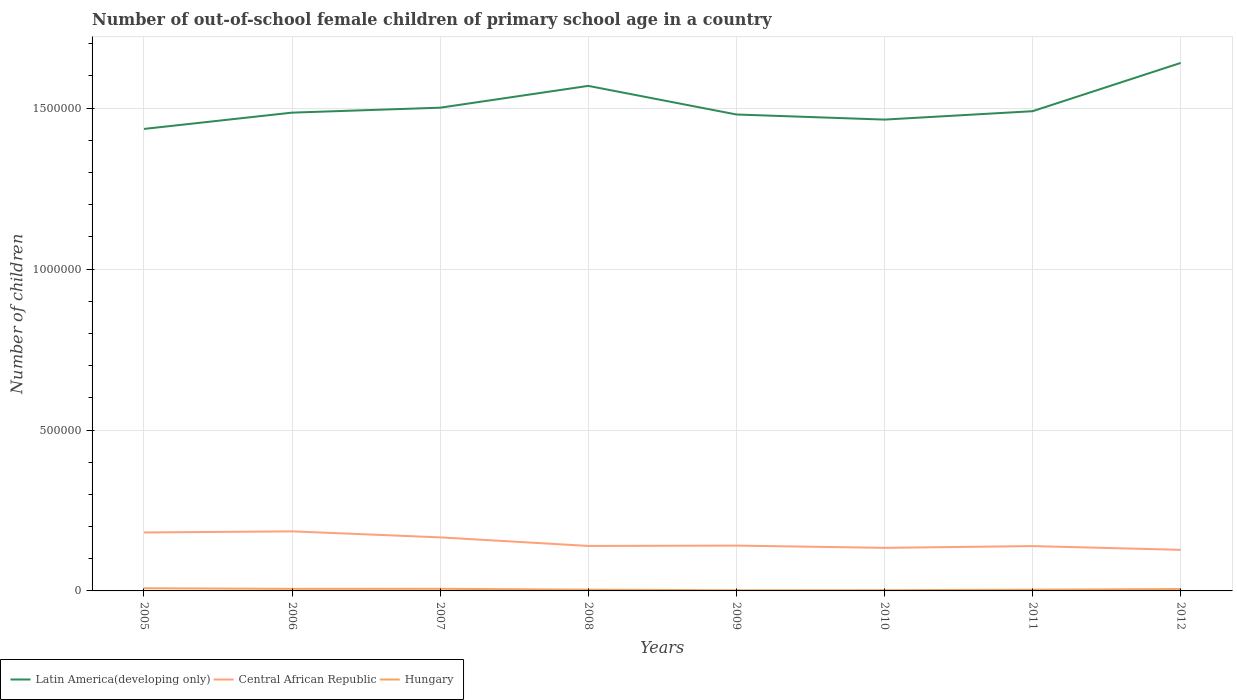How many different coloured lines are there?
Ensure brevity in your answer.  3. Does the line corresponding to Hungary intersect with the line corresponding to Central African Republic?
Your answer should be compact. No. Across all years, what is the maximum number of out-of-school female children in Central African Republic?
Offer a terse response. 1.28e+05. In which year was the number of out-of-school female children in Hungary maximum?
Offer a terse response. 2009. What is the total number of out-of-school female children in Hungary in the graph?
Give a very brief answer. 1621. What is the difference between the highest and the second highest number of out-of-school female children in Central African Republic?
Offer a terse response. 5.74e+04. How many years are there in the graph?
Offer a very short reply. 8. What is the difference between two consecutive major ticks on the Y-axis?
Provide a succinct answer. 5.00e+05. Are the values on the major ticks of Y-axis written in scientific E-notation?
Your answer should be compact. No. Does the graph contain any zero values?
Offer a very short reply. No. Does the graph contain grids?
Make the answer very short. Yes. How are the legend labels stacked?
Provide a succinct answer. Horizontal. What is the title of the graph?
Give a very brief answer. Number of out-of-school female children of primary school age in a country. Does "Serbia" appear as one of the legend labels in the graph?
Offer a very short reply. No. What is the label or title of the Y-axis?
Your response must be concise. Number of children. What is the Number of children in Latin America(developing only) in 2005?
Provide a short and direct response. 1.44e+06. What is the Number of children in Central African Republic in 2005?
Provide a short and direct response. 1.82e+05. What is the Number of children of Hungary in 2005?
Give a very brief answer. 8210. What is the Number of children of Latin America(developing only) in 2006?
Keep it short and to the point. 1.49e+06. What is the Number of children in Central African Republic in 2006?
Offer a terse response. 1.85e+05. What is the Number of children in Hungary in 2006?
Ensure brevity in your answer.  6465. What is the Number of children of Latin America(developing only) in 2007?
Offer a terse response. 1.50e+06. What is the Number of children in Central African Republic in 2007?
Give a very brief answer. 1.66e+05. What is the Number of children in Hungary in 2007?
Keep it short and to the point. 6589. What is the Number of children in Latin America(developing only) in 2008?
Give a very brief answer. 1.57e+06. What is the Number of children of Central African Republic in 2008?
Make the answer very short. 1.40e+05. What is the Number of children in Hungary in 2008?
Your response must be concise. 3879. What is the Number of children in Latin America(developing only) in 2009?
Your answer should be very brief. 1.48e+06. What is the Number of children of Central African Republic in 2009?
Ensure brevity in your answer.  1.41e+05. What is the Number of children in Hungary in 2009?
Your answer should be compact. 2098. What is the Number of children of Latin America(developing only) in 2010?
Offer a terse response. 1.46e+06. What is the Number of children of Central African Republic in 2010?
Your answer should be compact. 1.34e+05. What is the Number of children in Hungary in 2010?
Ensure brevity in your answer.  2276. What is the Number of children of Latin America(developing only) in 2011?
Ensure brevity in your answer.  1.49e+06. What is the Number of children of Central African Republic in 2011?
Your answer should be very brief. 1.39e+05. What is the Number of children in Hungary in 2011?
Your response must be concise. 3832. What is the Number of children of Latin America(developing only) in 2012?
Your response must be concise. 1.64e+06. What is the Number of children of Central African Republic in 2012?
Your response must be concise. 1.28e+05. What is the Number of children of Hungary in 2012?
Your response must be concise. 5886. Across all years, what is the maximum Number of children of Latin America(developing only)?
Offer a very short reply. 1.64e+06. Across all years, what is the maximum Number of children of Central African Republic?
Offer a very short reply. 1.85e+05. Across all years, what is the maximum Number of children of Hungary?
Keep it short and to the point. 8210. Across all years, what is the minimum Number of children of Latin America(developing only)?
Provide a succinct answer. 1.44e+06. Across all years, what is the minimum Number of children in Central African Republic?
Your answer should be very brief. 1.28e+05. Across all years, what is the minimum Number of children in Hungary?
Offer a terse response. 2098. What is the total Number of children of Latin America(developing only) in the graph?
Make the answer very short. 1.21e+07. What is the total Number of children of Central African Republic in the graph?
Your answer should be very brief. 1.21e+06. What is the total Number of children of Hungary in the graph?
Your answer should be very brief. 3.92e+04. What is the difference between the Number of children of Latin America(developing only) in 2005 and that in 2006?
Your response must be concise. -5.06e+04. What is the difference between the Number of children in Central African Republic in 2005 and that in 2006?
Make the answer very short. -3494. What is the difference between the Number of children of Hungary in 2005 and that in 2006?
Give a very brief answer. 1745. What is the difference between the Number of children in Latin America(developing only) in 2005 and that in 2007?
Ensure brevity in your answer.  -6.60e+04. What is the difference between the Number of children of Central African Republic in 2005 and that in 2007?
Keep it short and to the point. 1.52e+04. What is the difference between the Number of children in Hungary in 2005 and that in 2007?
Ensure brevity in your answer.  1621. What is the difference between the Number of children of Latin America(developing only) in 2005 and that in 2008?
Offer a terse response. -1.34e+05. What is the difference between the Number of children of Central African Republic in 2005 and that in 2008?
Ensure brevity in your answer.  4.18e+04. What is the difference between the Number of children in Hungary in 2005 and that in 2008?
Offer a terse response. 4331. What is the difference between the Number of children in Latin America(developing only) in 2005 and that in 2009?
Provide a short and direct response. -4.49e+04. What is the difference between the Number of children of Central African Republic in 2005 and that in 2009?
Provide a short and direct response. 4.08e+04. What is the difference between the Number of children in Hungary in 2005 and that in 2009?
Offer a very short reply. 6112. What is the difference between the Number of children in Latin America(developing only) in 2005 and that in 2010?
Your answer should be very brief. -2.90e+04. What is the difference between the Number of children of Central African Republic in 2005 and that in 2010?
Your answer should be very brief. 4.77e+04. What is the difference between the Number of children of Hungary in 2005 and that in 2010?
Make the answer very short. 5934. What is the difference between the Number of children of Latin America(developing only) in 2005 and that in 2011?
Provide a short and direct response. -5.51e+04. What is the difference between the Number of children of Central African Republic in 2005 and that in 2011?
Offer a very short reply. 4.23e+04. What is the difference between the Number of children of Hungary in 2005 and that in 2011?
Keep it short and to the point. 4378. What is the difference between the Number of children of Latin America(developing only) in 2005 and that in 2012?
Your response must be concise. -2.05e+05. What is the difference between the Number of children of Central African Republic in 2005 and that in 2012?
Provide a short and direct response. 5.39e+04. What is the difference between the Number of children in Hungary in 2005 and that in 2012?
Your answer should be compact. 2324. What is the difference between the Number of children in Latin America(developing only) in 2006 and that in 2007?
Make the answer very short. -1.53e+04. What is the difference between the Number of children of Central African Republic in 2006 and that in 2007?
Provide a succinct answer. 1.87e+04. What is the difference between the Number of children of Hungary in 2006 and that in 2007?
Your response must be concise. -124. What is the difference between the Number of children of Latin America(developing only) in 2006 and that in 2008?
Your response must be concise. -8.31e+04. What is the difference between the Number of children in Central African Republic in 2006 and that in 2008?
Your answer should be very brief. 4.53e+04. What is the difference between the Number of children of Hungary in 2006 and that in 2008?
Keep it short and to the point. 2586. What is the difference between the Number of children of Latin America(developing only) in 2006 and that in 2009?
Provide a succinct answer. 5729. What is the difference between the Number of children in Central African Republic in 2006 and that in 2009?
Your answer should be compact. 4.43e+04. What is the difference between the Number of children of Hungary in 2006 and that in 2009?
Provide a short and direct response. 4367. What is the difference between the Number of children of Latin America(developing only) in 2006 and that in 2010?
Keep it short and to the point. 2.16e+04. What is the difference between the Number of children in Central African Republic in 2006 and that in 2010?
Provide a succinct answer. 5.12e+04. What is the difference between the Number of children in Hungary in 2006 and that in 2010?
Give a very brief answer. 4189. What is the difference between the Number of children in Latin America(developing only) in 2006 and that in 2011?
Make the answer very short. -4454. What is the difference between the Number of children of Central African Republic in 2006 and that in 2011?
Offer a terse response. 4.58e+04. What is the difference between the Number of children in Hungary in 2006 and that in 2011?
Offer a terse response. 2633. What is the difference between the Number of children in Latin America(developing only) in 2006 and that in 2012?
Your answer should be compact. -1.54e+05. What is the difference between the Number of children of Central African Republic in 2006 and that in 2012?
Provide a short and direct response. 5.74e+04. What is the difference between the Number of children of Hungary in 2006 and that in 2012?
Provide a succinct answer. 579. What is the difference between the Number of children of Latin America(developing only) in 2007 and that in 2008?
Provide a succinct answer. -6.78e+04. What is the difference between the Number of children of Central African Republic in 2007 and that in 2008?
Ensure brevity in your answer.  2.66e+04. What is the difference between the Number of children in Hungary in 2007 and that in 2008?
Make the answer very short. 2710. What is the difference between the Number of children in Latin America(developing only) in 2007 and that in 2009?
Make the answer very short. 2.11e+04. What is the difference between the Number of children in Central African Republic in 2007 and that in 2009?
Provide a succinct answer. 2.56e+04. What is the difference between the Number of children in Hungary in 2007 and that in 2009?
Make the answer very short. 4491. What is the difference between the Number of children of Latin America(developing only) in 2007 and that in 2010?
Your answer should be compact. 3.70e+04. What is the difference between the Number of children of Central African Republic in 2007 and that in 2010?
Your response must be concise. 3.25e+04. What is the difference between the Number of children of Hungary in 2007 and that in 2010?
Your answer should be compact. 4313. What is the difference between the Number of children in Latin America(developing only) in 2007 and that in 2011?
Your answer should be very brief. 1.09e+04. What is the difference between the Number of children of Central African Republic in 2007 and that in 2011?
Provide a short and direct response. 2.71e+04. What is the difference between the Number of children in Hungary in 2007 and that in 2011?
Offer a terse response. 2757. What is the difference between the Number of children in Latin America(developing only) in 2007 and that in 2012?
Ensure brevity in your answer.  -1.39e+05. What is the difference between the Number of children of Central African Republic in 2007 and that in 2012?
Offer a terse response. 3.87e+04. What is the difference between the Number of children in Hungary in 2007 and that in 2012?
Give a very brief answer. 703. What is the difference between the Number of children in Latin America(developing only) in 2008 and that in 2009?
Offer a very short reply. 8.88e+04. What is the difference between the Number of children in Central African Republic in 2008 and that in 2009?
Your answer should be compact. -1034. What is the difference between the Number of children of Hungary in 2008 and that in 2009?
Ensure brevity in your answer.  1781. What is the difference between the Number of children in Latin America(developing only) in 2008 and that in 2010?
Your answer should be very brief. 1.05e+05. What is the difference between the Number of children in Central African Republic in 2008 and that in 2010?
Ensure brevity in your answer.  5907. What is the difference between the Number of children of Hungary in 2008 and that in 2010?
Ensure brevity in your answer.  1603. What is the difference between the Number of children in Latin America(developing only) in 2008 and that in 2011?
Offer a very short reply. 7.87e+04. What is the difference between the Number of children of Central African Republic in 2008 and that in 2011?
Make the answer very short. 487. What is the difference between the Number of children in Latin America(developing only) in 2008 and that in 2012?
Make the answer very short. -7.13e+04. What is the difference between the Number of children in Central African Republic in 2008 and that in 2012?
Offer a very short reply. 1.21e+04. What is the difference between the Number of children of Hungary in 2008 and that in 2012?
Provide a succinct answer. -2007. What is the difference between the Number of children in Latin America(developing only) in 2009 and that in 2010?
Ensure brevity in your answer.  1.59e+04. What is the difference between the Number of children of Central African Republic in 2009 and that in 2010?
Ensure brevity in your answer.  6941. What is the difference between the Number of children of Hungary in 2009 and that in 2010?
Your answer should be compact. -178. What is the difference between the Number of children in Latin America(developing only) in 2009 and that in 2011?
Offer a very short reply. -1.02e+04. What is the difference between the Number of children in Central African Republic in 2009 and that in 2011?
Offer a terse response. 1521. What is the difference between the Number of children in Hungary in 2009 and that in 2011?
Make the answer very short. -1734. What is the difference between the Number of children in Latin America(developing only) in 2009 and that in 2012?
Offer a terse response. -1.60e+05. What is the difference between the Number of children in Central African Republic in 2009 and that in 2012?
Offer a terse response. 1.31e+04. What is the difference between the Number of children in Hungary in 2009 and that in 2012?
Your answer should be compact. -3788. What is the difference between the Number of children of Latin America(developing only) in 2010 and that in 2011?
Provide a short and direct response. -2.61e+04. What is the difference between the Number of children in Central African Republic in 2010 and that in 2011?
Offer a terse response. -5420. What is the difference between the Number of children of Hungary in 2010 and that in 2011?
Give a very brief answer. -1556. What is the difference between the Number of children in Latin America(developing only) in 2010 and that in 2012?
Give a very brief answer. -1.76e+05. What is the difference between the Number of children of Central African Republic in 2010 and that in 2012?
Give a very brief answer. 6178. What is the difference between the Number of children in Hungary in 2010 and that in 2012?
Keep it short and to the point. -3610. What is the difference between the Number of children in Latin America(developing only) in 2011 and that in 2012?
Give a very brief answer. -1.50e+05. What is the difference between the Number of children of Central African Republic in 2011 and that in 2012?
Provide a succinct answer. 1.16e+04. What is the difference between the Number of children in Hungary in 2011 and that in 2012?
Ensure brevity in your answer.  -2054. What is the difference between the Number of children in Latin America(developing only) in 2005 and the Number of children in Central African Republic in 2006?
Provide a succinct answer. 1.25e+06. What is the difference between the Number of children in Latin America(developing only) in 2005 and the Number of children in Hungary in 2006?
Provide a succinct answer. 1.43e+06. What is the difference between the Number of children in Central African Republic in 2005 and the Number of children in Hungary in 2006?
Keep it short and to the point. 1.75e+05. What is the difference between the Number of children in Latin America(developing only) in 2005 and the Number of children in Central African Republic in 2007?
Ensure brevity in your answer.  1.27e+06. What is the difference between the Number of children of Latin America(developing only) in 2005 and the Number of children of Hungary in 2007?
Keep it short and to the point. 1.43e+06. What is the difference between the Number of children in Central African Republic in 2005 and the Number of children in Hungary in 2007?
Provide a short and direct response. 1.75e+05. What is the difference between the Number of children of Latin America(developing only) in 2005 and the Number of children of Central African Republic in 2008?
Offer a terse response. 1.30e+06. What is the difference between the Number of children of Latin America(developing only) in 2005 and the Number of children of Hungary in 2008?
Your answer should be very brief. 1.43e+06. What is the difference between the Number of children in Central African Republic in 2005 and the Number of children in Hungary in 2008?
Keep it short and to the point. 1.78e+05. What is the difference between the Number of children in Latin America(developing only) in 2005 and the Number of children in Central African Republic in 2009?
Offer a very short reply. 1.29e+06. What is the difference between the Number of children of Latin America(developing only) in 2005 and the Number of children of Hungary in 2009?
Offer a very short reply. 1.43e+06. What is the difference between the Number of children of Central African Republic in 2005 and the Number of children of Hungary in 2009?
Keep it short and to the point. 1.80e+05. What is the difference between the Number of children in Latin America(developing only) in 2005 and the Number of children in Central African Republic in 2010?
Keep it short and to the point. 1.30e+06. What is the difference between the Number of children of Latin America(developing only) in 2005 and the Number of children of Hungary in 2010?
Make the answer very short. 1.43e+06. What is the difference between the Number of children in Central African Republic in 2005 and the Number of children in Hungary in 2010?
Provide a short and direct response. 1.79e+05. What is the difference between the Number of children of Latin America(developing only) in 2005 and the Number of children of Central African Republic in 2011?
Ensure brevity in your answer.  1.30e+06. What is the difference between the Number of children of Latin America(developing only) in 2005 and the Number of children of Hungary in 2011?
Your answer should be very brief. 1.43e+06. What is the difference between the Number of children in Central African Republic in 2005 and the Number of children in Hungary in 2011?
Keep it short and to the point. 1.78e+05. What is the difference between the Number of children in Latin America(developing only) in 2005 and the Number of children in Central African Republic in 2012?
Your answer should be very brief. 1.31e+06. What is the difference between the Number of children of Latin America(developing only) in 2005 and the Number of children of Hungary in 2012?
Keep it short and to the point. 1.43e+06. What is the difference between the Number of children in Central African Republic in 2005 and the Number of children in Hungary in 2012?
Offer a terse response. 1.76e+05. What is the difference between the Number of children in Latin America(developing only) in 2006 and the Number of children in Central African Republic in 2007?
Offer a terse response. 1.32e+06. What is the difference between the Number of children in Latin America(developing only) in 2006 and the Number of children in Hungary in 2007?
Your answer should be very brief. 1.48e+06. What is the difference between the Number of children in Central African Republic in 2006 and the Number of children in Hungary in 2007?
Your answer should be compact. 1.79e+05. What is the difference between the Number of children in Latin America(developing only) in 2006 and the Number of children in Central African Republic in 2008?
Make the answer very short. 1.35e+06. What is the difference between the Number of children of Latin America(developing only) in 2006 and the Number of children of Hungary in 2008?
Your response must be concise. 1.48e+06. What is the difference between the Number of children of Central African Republic in 2006 and the Number of children of Hungary in 2008?
Your response must be concise. 1.81e+05. What is the difference between the Number of children in Latin America(developing only) in 2006 and the Number of children in Central African Republic in 2009?
Provide a short and direct response. 1.35e+06. What is the difference between the Number of children of Latin America(developing only) in 2006 and the Number of children of Hungary in 2009?
Your response must be concise. 1.48e+06. What is the difference between the Number of children in Central African Republic in 2006 and the Number of children in Hungary in 2009?
Ensure brevity in your answer.  1.83e+05. What is the difference between the Number of children of Latin America(developing only) in 2006 and the Number of children of Central African Republic in 2010?
Your answer should be very brief. 1.35e+06. What is the difference between the Number of children in Latin America(developing only) in 2006 and the Number of children in Hungary in 2010?
Offer a very short reply. 1.48e+06. What is the difference between the Number of children of Central African Republic in 2006 and the Number of children of Hungary in 2010?
Keep it short and to the point. 1.83e+05. What is the difference between the Number of children in Latin America(developing only) in 2006 and the Number of children in Central African Republic in 2011?
Ensure brevity in your answer.  1.35e+06. What is the difference between the Number of children of Latin America(developing only) in 2006 and the Number of children of Hungary in 2011?
Offer a terse response. 1.48e+06. What is the difference between the Number of children in Central African Republic in 2006 and the Number of children in Hungary in 2011?
Offer a terse response. 1.81e+05. What is the difference between the Number of children of Latin America(developing only) in 2006 and the Number of children of Central African Republic in 2012?
Provide a short and direct response. 1.36e+06. What is the difference between the Number of children in Latin America(developing only) in 2006 and the Number of children in Hungary in 2012?
Provide a short and direct response. 1.48e+06. What is the difference between the Number of children of Central African Republic in 2006 and the Number of children of Hungary in 2012?
Make the answer very short. 1.79e+05. What is the difference between the Number of children of Latin America(developing only) in 2007 and the Number of children of Central African Republic in 2008?
Provide a short and direct response. 1.36e+06. What is the difference between the Number of children of Latin America(developing only) in 2007 and the Number of children of Hungary in 2008?
Your answer should be compact. 1.50e+06. What is the difference between the Number of children of Central African Republic in 2007 and the Number of children of Hungary in 2008?
Your answer should be compact. 1.63e+05. What is the difference between the Number of children in Latin America(developing only) in 2007 and the Number of children in Central African Republic in 2009?
Offer a very short reply. 1.36e+06. What is the difference between the Number of children in Latin America(developing only) in 2007 and the Number of children in Hungary in 2009?
Keep it short and to the point. 1.50e+06. What is the difference between the Number of children in Central African Republic in 2007 and the Number of children in Hungary in 2009?
Your response must be concise. 1.64e+05. What is the difference between the Number of children of Latin America(developing only) in 2007 and the Number of children of Central African Republic in 2010?
Provide a short and direct response. 1.37e+06. What is the difference between the Number of children of Latin America(developing only) in 2007 and the Number of children of Hungary in 2010?
Provide a short and direct response. 1.50e+06. What is the difference between the Number of children of Central African Republic in 2007 and the Number of children of Hungary in 2010?
Provide a short and direct response. 1.64e+05. What is the difference between the Number of children in Latin America(developing only) in 2007 and the Number of children in Central African Republic in 2011?
Offer a terse response. 1.36e+06. What is the difference between the Number of children of Latin America(developing only) in 2007 and the Number of children of Hungary in 2011?
Ensure brevity in your answer.  1.50e+06. What is the difference between the Number of children in Central African Republic in 2007 and the Number of children in Hungary in 2011?
Your answer should be compact. 1.63e+05. What is the difference between the Number of children in Latin America(developing only) in 2007 and the Number of children in Central African Republic in 2012?
Give a very brief answer. 1.37e+06. What is the difference between the Number of children in Latin America(developing only) in 2007 and the Number of children in Hungary in 2012?
Your response must be concise. 1.50e+06. What is the difference between the Number of children of Central African Republic in 2007 and the Number of children of Hungary in 2012?
Your response must be concise. 1.61e+05. What is the difference between the Number of children in Latin America(developing only) in 2008 and the Number of children in Central African Republic in 2009?
Your answer should be very brief. 1.43e+06. What is the difference between the Number of children in Latin America(developing only) in 2008 and the Number of children in Hungary in 2009?
Offer a very short reply. 1.57e+06. What is the difference between the Number of children of Central African Republic in 2008 and the Number of children of Hungary in 2009?
Offer a very short reply. 1.38e+05. What is the difference between the Number of children in Latin America(developing only) in 2008 and the Number of children in Central African Republic in 2010?
Keep it short and to the point. 1.44e+06. What is the difference between the Number of children in Latin America(developing only) in 2008 and the Number of children in Hungary in 2010?
Provide a succinct answer. 1.57e+06. What is the difference between the Number of children in Central African Republic in 2008 and the Number of children in Hungary in 2010?
Make the answer very short. 1.37e+05. What is the difference between the Number of children in Latin America(developing only) in 2008 and the Number of children in Central African Republic in 2011?
Your response must be concise. 1.43e+06. What is the difference between the Number of children in Latin America(developing only) in 2008 and the Number of children in Hungary in 2011?
Offer a very short reply. 1.57e+06. What is the difference between the Number of children of Central African Republic in 2008 and the Number of children of Hungary in 2011?
Ensure brevity in your answer.  1.36e+05. What is the difference between the Number of children of Latin America(developing only) in 2008 and the Number of children of Central African Republic in 2012?
Make the answer very short. 1.44e+06. What is the difference between the Number of children in Latin America(developing only) in 2008 and the Number of children in Hungary in 2012?
Ensure brevity in your answer.  1.56e+06. What is the difference between the Number of children of Central African Republic in 2008 and the Number of children of Hungary in 2012?
Provide a short and direct response. 1.34e+05. What is the difference between the Number of children of Latin America(developing only) in 2009 and the Number of children of Central African Republic in 2010?
Your answer should be compact. 1.35e+06. What is the difference between the Number of children in Latin America(developing only) in 2009 and the Number of children in Hungary in 2010?
Your answer should be very brief. 1.48e+06. What is the difference between the Number of children of Central African Republic in 2009 and the Number of children of Hungary in 2010?
Offer a very short reply. 1.39e+05. What is the difference between the Number of children in Latin America(developing only) in 2009 and the Number of children in Central African Republic in 2011?
Your answer should be very brief. 1.34e+06. What is the difference between the Number of children of Latin America(developing only) in 2009 and the Number of children of Hungary in 2011?
Make the answer very short. 1.48e+06. What is the difference between the Number of children of Central African Republic in 2009 and the Number of children of Hungary in 2011?
Your response must be concise. 1.37e+05. What is the difference between the Number of children in Latin America(developing only) in 2009 and the Number of children in Central African Republic in 2012?
Offer a very short reply. 1.35e+06. What is the difference between the Number of children in Latin America(developing only) in 2009 and the Number of children in Hungary in 2012?
Give a very brief answer. 1.47e+06. What is the difference between the Number of children in Central African Republic in 2009 and the Number of children in Hungary in 2012?
Keep it short and to the point. 1.35e+05. What is the difference between the Number of children of Latin America(developing only) in 2010 and the Number of children of Central African Republic in 2011?
Make the answer very short. 1.33e+06. What is the difference between the Number of children of Latin America(developing only) in 2010 and the Number of children of Hungary in 2011?
Ensure brevity in your answer.  1.46e+06. What is the difference between the Number of children of Central African Republic in 2010 and the Number of children of Hungary in 2011?
Your answer should be compact. 1.30e+05. What is the difference between the Number of children in Latin America(developing only) in 2010 and the Number of children in Central African Republic in 2012?
Offer a terse response. 1.34e+06. What is the difference between the Number of children in Latin America(developing only) in 2010 and the Number of children in Hungary in 2012?
Offer a very short reply. 1.46e+06. What is the difference between the Number of children of Central African Republic in 2010 and the Number of children of Hungary in 2012?
Make the answer very short. 1.28e+05. What is the difference between the Number of children in Latin America(developing only) in 2011 and the Number of children in Central African Republic in 2012?
Provide a short and direct response. 1.36e+06. What is the difference between the Number of children of Latin America(developing only) in 2011 and the Number of children of Hungary in 2012?
Your response must be concise. 1.48e+06. What is the difference between the Number of children of Central African Republic in 2011 and the Number of children of Hungary in 2012?
Your response must be concise. 1.33e+05. What is the average Number of children of Latin America(developing only) per year?
Your answer should be very brief. 1.51e+06. What is the average Number of children of Central African Republic per year?
Make the answer very short. 1.52e+05. What is the average Number of children of Hungary per year?
Give a very brief answer. 4904.38. In the year 2005, what is the difference between the Number of children in Latin America(developing only) and Number of children in Central African Republic?
Your response must be concise. 1.25e+06. In the year 2005, what is the difference between the Number of children of Latin America(developing only) and Number of children of Hungary?
Offer a terse response. 1.43e+06. In the year 2005, what is the difference between the Number of children of Central African Republic and Number of children of Hungary?
Your answer should be compact. 1.73e+05. In the year 2006, what is the difference between the Number of children of Latin America(developing only) and Number of children of Central African Republic?
Give a very brief answer. 1.30e+06. In the year 2006, what is the difference between the Number of children of Latin America(developing only) and Number of children of Hungary?
Your response must be concise. 1.48e+06. In the year 2006, what is the difference between the Number of children in Central African Republic and Number of children in Hungary?
Provide a short and direct response. 1.79e+05. In the year 2007, what is the difference between the Number of children in Latin America(developing only) and Number of children in Central African Republic?
Make the answer very short. 1.34e+06. In the year 2007, what is the difference between the Number of children in Latin America(developing only) and Number of children in Hungary?
Provide a succinct answer. 1.49e+06. In the year 2007, what is the difference between the Number of children of Central African Republic and Number of children of Hungary?
Your response must be concise. 1.60e+05. In the year 2008, what is the difference between the Number of children in Latin America(developing only) and Number of children in Central African Republic?
Make the answer very short. 1.43e+06. In the year 2008, what is the difference between the Number of children in Latin America(developing only) and Number of children in Hungary?
Provide a short and direct response. 1.57e+06. In the year 2008, what is the difference between the Number of children of Central African Republic and Number of children of Hungary?
Provide a short and direct response. 1.36e+05. In the year 2009, what is the difference between the Number of children of Latin America(developing only) and Number of children of Central African Republic?
Your answer should be very brief. 1.34e+06. In the year 2009, what is the difference between the Number of children in Latin America(developing only) and Number of children in Hungary?
Offer a very short reply. 1.48e+06. In the year 2009, what is the difference between the Number of children of Central African Republic and Number of children of Hungary?
Offer a terse response. 1.39e+05. In the year 2010, what is the difference between the Number of children of Latin America(developing only) and Number of children of Central African Republic?
Provide a short and direct response. 1.33e+06. In the year 2010, what is the difference between the Number of children in Latin America(developing only) and Number of children in Hungary?
Your answer should be compact. 1.46e+06. In the year 2010, what is the difference between the Number of children of Central African Republic and Number of children of Hungary?
Offer a terse response. 1.32e+05. In the year 2011, what is the difference between the Number of children of Latin America(developing only) and Number of children of Central African Republic?
Ensure brevity in your answer.  1.35e+06. In the year 2011, what is the difference between the Number of children in Latin America(developing only) and Number of children in Hungary?
Your response must be concise. 1.49e+06. In the year 2011, what is the difference between the Number of children in Central African Republic and Number of children in Hungary?
Keep it short and to the point. 1.35e+05. In the year 2012, what is the difference between the Number of children of Latin America(developing only) and Number of children of Central African Republic?
Offer a terse response. 1.51e+06. In the year 2012, what is the difference between the Number of children in Latin America(developing only) and Number of children in Hungary?
Your response must be concise. 1.63e+06. In the year 2012, what is the difference between the Number of children of Central African Republic and Number of children of Hungary?
Make the answer very short. 1.22e+05. What is the ratio of the Number of children of Latin America(developing only) in 2005 to that in 2006?
Offer a very short reply. 0.97. What is the ratio of the Number of children of Central African Republic in 2005 to that in 2006?
Your answer should be very brief. 0.98. What is the ratio of the Number of children of Hungary in 2005 to that in 2006?
Your answer should be very brief. 1.27. What is the ratio of the Number of children of Latin America(developing only) in 2005 to that in 2007?
Offer a very short reply. 0.96. What is the ratio of the Number of children of Central African Republic in 2005 to that in 2007?
Your response must be concise. 1.09. What is the ratio of the Number of children in Hungary in 2005 to that in 2007?
Keep it short and to the point. 1.25. What is the ratio of the Number of children of Latin America(developing only) in 2005 to that in 2008?
Give a very brief answer. 0.91. What is the ratio of the Number of children in Central African Republic in 2005 to that in 2008?
Your answer should be very brief. 1.3. What is the ratio of the Number of children of Hungary in 2005 to that in 2008?
Give a very brief answer. 2.12. What is the ratio of the Number of children of Latin America(developing only) in 2005 to that in 2009?
Offer a very short reply. 0.97. What is the ratio of the Number of children in Central African Republic in 2005 to that in 2009?
Offer a very short reply. 1.29. What is the ratio of the Number of children in Hungary in 2005 to that in 2009?
Ensure brevity in your answer.  3.91. What is the ratio of the Number of children in Latin America(developing only) in 2005 to that in 2010?
Your answer should be compact. 0.98. What is the ratio of the Number of children in Central African Republic in 2005 to that in 2010?
Your answer should be compact. 1.36. What is the ratio of the Number of children in Hungary in 2005 to that in 2010?
Give a very brief answer. 3.61. What is the ratio of the Number of children in Latin America(developing only) in 2005 to that in 2011?
Make the answer very short. 0.96. What is the ratio of the Number of children in Central African Republic in 2005 to that in 2011?
Offer a very short reply. 1.3. What is the ratio of the Number of children of Hungary in 2005 to that in 2011?
Offer a terse response. 2.14. What is the ratio of the Number of children in Latin America(developing only) in 2005 to that in 2012?
Your answer should be compact. 0.88. What is the ratio of the Number of children of Central African Republic in 2005 to that in 2012?
Your answer should be very brief. 1.42. What is the ratio of the Number of children of Hungary in 2005 to that in 2012?
Make the answer very short. 1.39. What is the ratio of the Number of children in Latin America(developing only) in 2006 to that in 2007?
Provide a short and direct response. 0.99. What is the ratio of the Number of children in Central African Republic in 2006 to that in 2007?
Provide a succinct answer. 1.11. What is the ratio of the Number of children of Hungary in 2006 to that in 2007?
Provide a succinct answer. 0.98. What is the ratio of the Number of children of Latin America(developing only) in 2006 to that in 2008?
Give a very brief answer. 0.95. What is the ratio of the Number of children in Central African Republic in 2006 to that in 2008?
Offer a very short reply. 1.32. What is the ratio of the Number of children in Hungary in 2006 to that in 2008?
Your response must be concise. 1.67. What is the ratio of the Number of children in Central African Republic in 2006 to that in 2009?
Offer a very short reply. 1.31. What is the ratio of the Number of children in Hungary in 2006 to that in 2009?
Offer a very short reply. 3.08. What is the ratio of the Number of children in Latin America(developing only) in 2006 to that in 2010?
Offer a terse response. 1.01. What is the ratio of the Number of children of Central African Republic in 2006 to that in 2010?
Give a very brief answer. 1.38. What is the ratio of the Number of children of Hungary in 2006 to that in 2010?
Give a very brief answer. 2.84. What is the ratio of the Number of children in Central African Republic in 2006 to that in 2011?
Ensure brevity in your answer.  1.33. What is the ratio of the Number of children of Hungary in 2006 to that in 2011?
Your answer should be compact. 1.69. What is the ratio of the Number of children of Latin America(developing only) in 2006 to that in 2012?
Give a very brief answer. 0.91. What is the ratio of the Number of children of Central African Republic in 2006 to that in 2012?
Provide a succinct answer. 1.45. What is the ratio of the Number of children in Hungary in 2006 to that in 2012?
Offer a terse response. 1.1. What is the ratio of the Number of children in Latin America(developing only) in 2007 to that in 2008?
Make the answer very short. 0.96. What is the ratio of the Number of children in Central African Republic in 2007 to that in 2008?
Ensure brevity in your answer.  1.19. What is the ratio of the Number of children in Hungary in 2007 to that in 2008?
Your answer should be compact. 1.7. What is the ratio of the Number of children of Latin America(developing only) in 2007 to that in 2009?
Keep it short and to the point. 1.01. What is the ratio of the Number of children in Central African Republic in 2007 to that in 2009?
Offer a very short reply. 1.18. What is the ratio of the Number of children of Hungary in 2007 to that in 2009?
Provide a short and direct response. 3.14. What is the ratio of the Number of children in Latin America(developing only) in 2007 to that in 2010?
Ensure brevity in your answer.  1.03. What is the ratio of the Number of children of Central African Republic in 2007 to that in 2010?
Provide a short and direct response. 1.24. What is the ratio of the Number of children in Hungary in 2007 to that in 2010?
Provide a short and direct response. 2.9. What is the ratio of the Number of children in Latin America(developing only) in 2007 to that in 2011?
Make the answer very short. 1.01. What is the ratio of the Number of children in Central African Republic in 2007 to that in 2011?
Keep it short and to the point. 1.19. What is the ratio of the Number of children in Hungary in 2007 to that in 2011?
Make the answer very short. 1.72. What is the ratio of the Number of children of Latin America(developing only) in 2007 to that in 2012?
Offer a terse response. 0.92. What is the ratio of the Number of children in Central African Republic in 2007 to that in 2012?
Provide a short and direct response. 1.3. What is the ratio of the Number of children in Hungary in 2007 to that in 2012?
Ensure brevity in your answer.  1.12. What is the ratio of the Number of children in Latin America(developing only) in 2008 to that in 2009?
Offer a very short reply. 1.06. What is the ratio of the Number of children in Hungary in 2008 to that in 2009?
Offer a terse response. 1.85. What is the ratio of the Number of children of Latin America(developing only) in 2008 to that in 2010?
Your answer should be very brief. 1.07. What is the ratio of the Number of children in Central African Republic in 2008 to that in 2010?
Offer a terse response. 1.04. What is the ratio of the Number of children in Hungary in 2008 to that in 2010?
Ensure brevity in your answer.  1.7. What is the ratio of the Number of children in Latin America(developing only) in 2008 to that in 2011?
Your answer should be very brief. 1.05. What is the ratio of the Number of children in Central African Republic in 2008 to that in 2011?
Offer a very short reply. 1. What is the ratio of the Number of children in Hungary in 2008 to that in 2011?
Keep it short and to the point. 1.01. What is the ratio of the Number of children in Latin America(developing only) in 2008 to that in 2012?
Offer a terse response. 0.96. What is the ratio of the Number of children of Central African Republic in 2008 to that in 2012?
Give a very brief answer. 1.09. What is the ratio of the Number of children of Hungary in 2008 to that in 2012?
Make the answer very short. 0.66. What is the ratio of the Number of children in Latin America(developing only) in 2009 to that in 2010?
Keep it short and to the point. 1.01. What is the ratio of the Number of children in Central African Republic in 2009 to that in 2010?
Offer a very short reply. 1.05. What is the ratio of the Number of children of Hungary in 2009 to that in 2010?
Your answer should be very brief. 0.92. What is the ratio of the Number of children of Latin America(developing only) in 2009 to that in 2011?
Give a very brief answer. 0.99. What is the ratio of the Number of children in Central African Republic in 2009 to that in 2011?
Provide a succinct answer. 1.01. What is the ratio of the Number of children of Hungary in 2009 to that in 2011?
Your answer should be very brief. 0.55. What is the ratio of the Number of children of Latin America(developing only) in 2009 to that in 2012?
Offer a terse response. 0.9. What is the ratio of the Number of children in Central African Republic in 2009 to that in 2012?
Keep it short and to the point. 1.1. What is the ratio of the Number of children of Hungary in 2009 to that in 2012?
Your response must be concise. 0.36. What is the ratio of the Number of children in Latin America(developing only) in 2010 to that in 2011?
Give a very brief answer. 0.98. What is the ratio of the Number of children of Central African Republic in 2010 to that in 2011?
Your answer should be compact. 0.96. What is the ratio of the Number of children of Hungary in 2010 to that in 2011?
Your answer should be compact. 0.59. What is the ratio of the Number of children in Latin America(developing only) in 2010 to that in 2012?
Ensure brevity in your answer.  0.89. What is the ratio of the Number of children of Central African Republic in 2010 to that in 2012?
Provide a short and direct response. 1.05. What is the ratio of the Number of children of Hungary in 2010 to that in 2012?
Your answer should be compact. 0.39. What is the ratio of the Number of children in Latin America(developing only) in 2011 to that in 2012?
Your answer should be compact. 0.91. What is the ratio of the Number of children in Central African Republic in 2011 to that in 2012?
Ensure brevity in your answer.  1.09. What is the ratio of the Number of children of Hungary in 2011 to that in 2012?
Ensure brevity in your answer.  0.65. What is the difference between the highest and the second highest Number of children in Latin America(developing only)?
Keep it short and to the point. 7.13e+04. What is the difference between the highest and the second highest Number of children in Central African Republic?
Give a very brief answer. 3494. What is the difference between the highest and the second highest Number of children in Hungary?
Your answer should be compact. 1621. What is the difference between the highest and the lowest Number of children of Latin America(developing only)?
Your answer should be compact. 2.05e+05. What is the difference between the highest and the lowest Number of children of Central African Republic?
Give a very brief answer. 5.74e+04. What is the difference between the highest and the lowest Number of children in Hungary?
Give a very brief answer. 6112. 